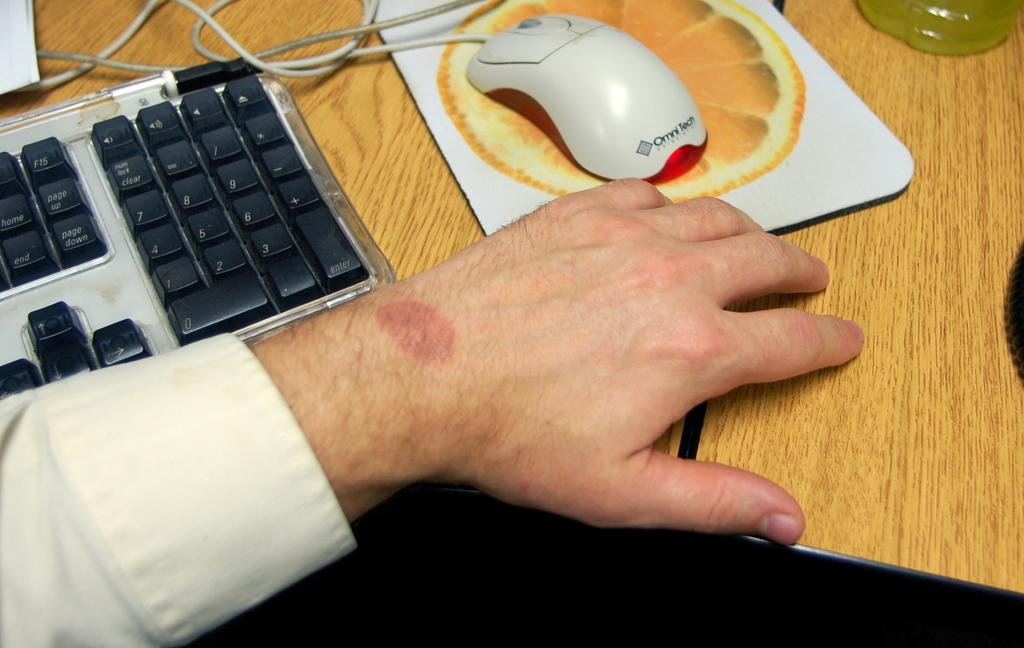What type of device is visible in the image? There is a keyboard in the image. What is used for input with the keyboard? There is a mouse in the image, which is used for input. What else can be seen in the image besides the keyboard and mouse? There is a bottle and wires visible in the image. Whose hand is visible in the image? A person's hand is visible in the image. What can be inferred about the location of the image? The image is likely taken in a room. What type of sack is being used to store popcorn in the image? There is no sack or popcorn present in the image; it features a keyboard, mouse, bottle, wires, and a person's hand. 